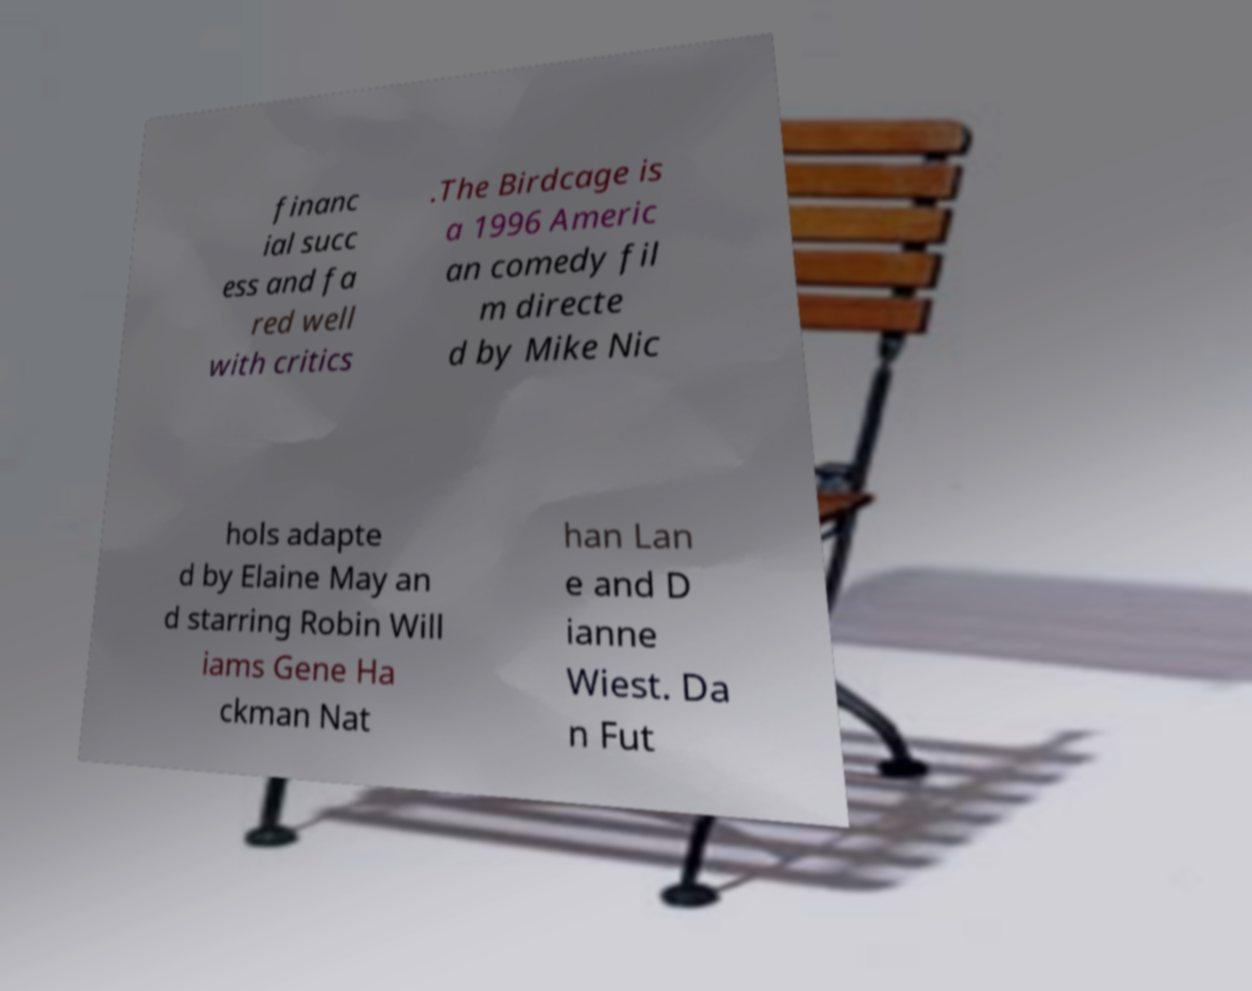Please read and relay the text visible in this image. What does it say? financ ial succ ess and fa red well with critics .The Birdcage is a 1996 Americ an comedy fil m directe d by Mike Nic hols adapte d by Elaine May an d starring Robin Will iams Gene Ha ckman Nat han Lan e and D ianne Wiest. Da n Fut 